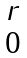<formula> <loc_0><loc_0><loc_500><loc_500>\begin{matrix} r \\ 0 \end{matrix}</formula> 